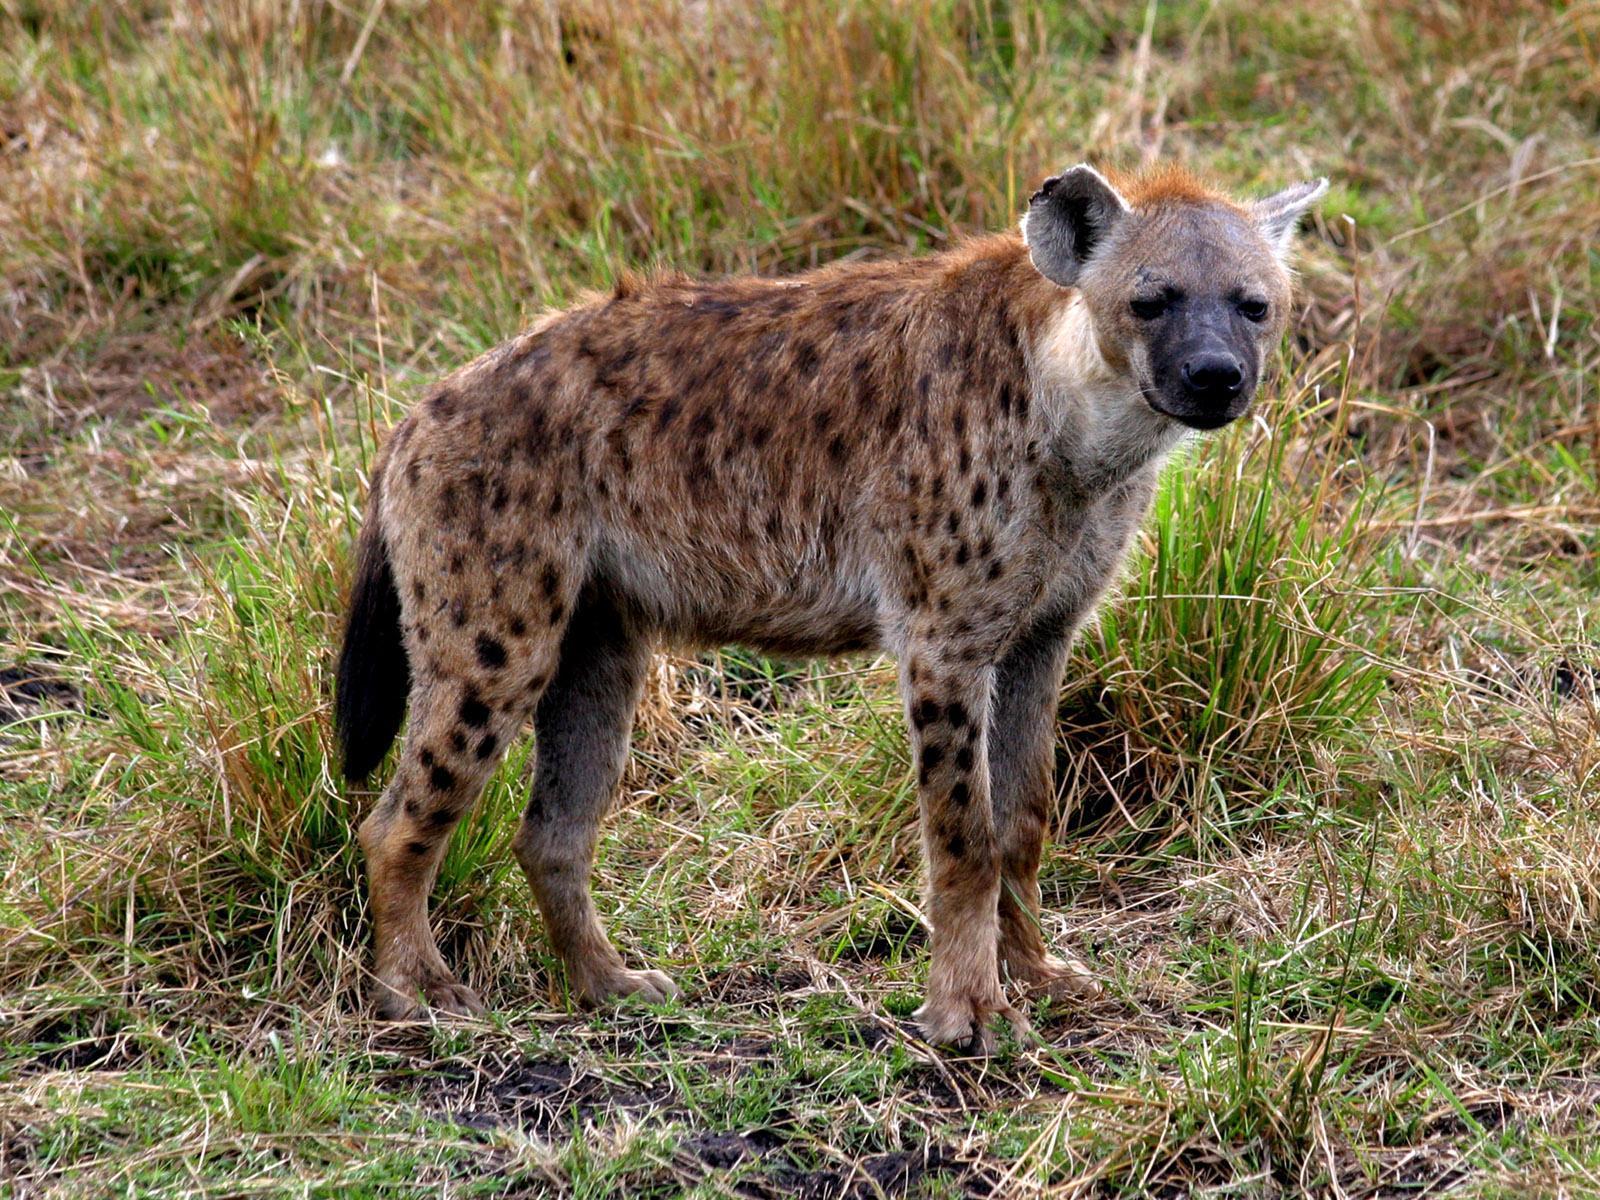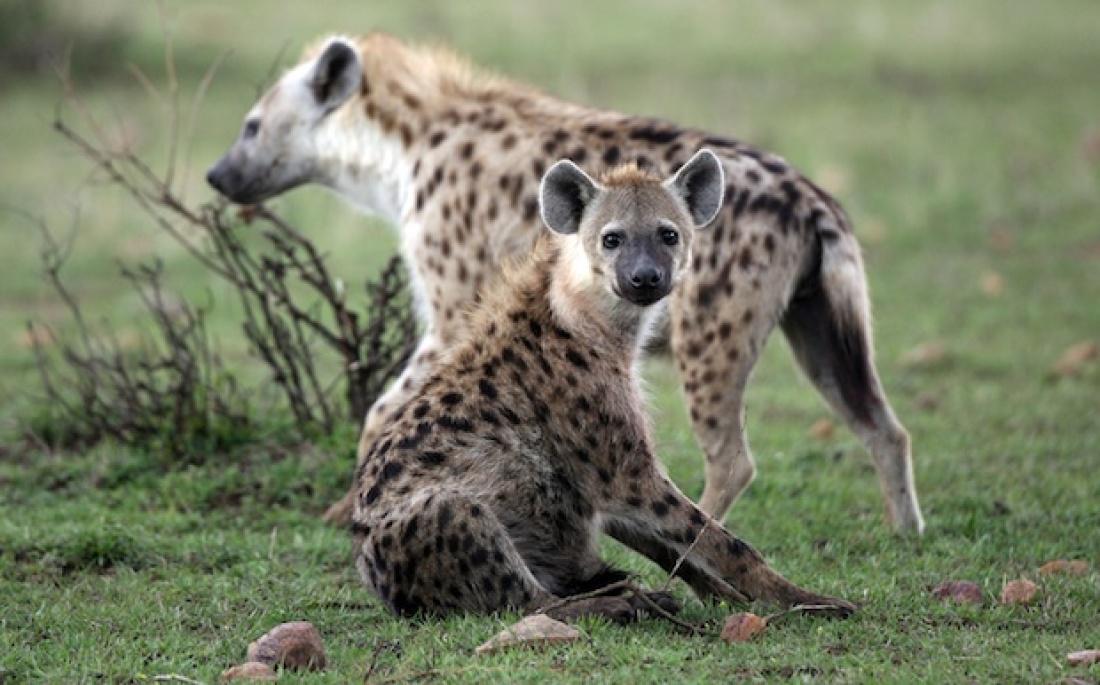The first image is the image on the left, the second image is the image on the right. Evaluate the accuracy of this statement regarding the images: "There are two hyenas in a photo.". Is it true? Answer yes or no. Yes. 